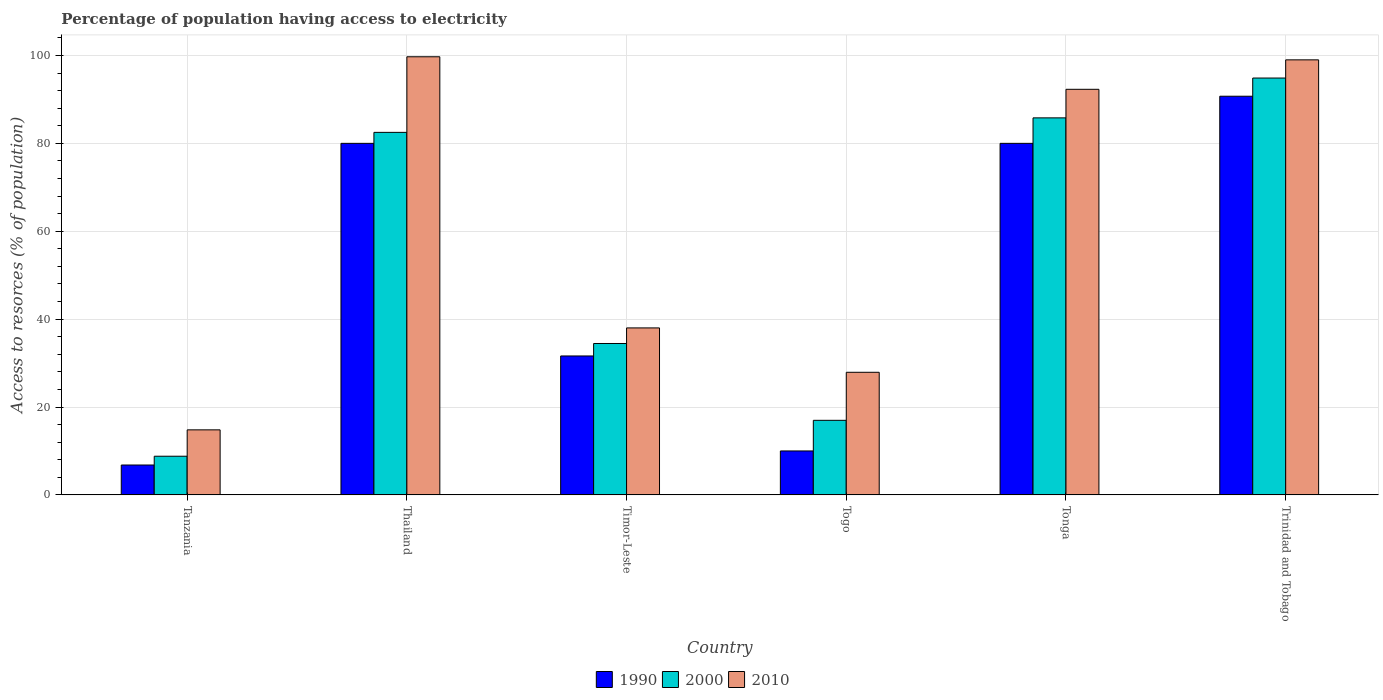How many groups of bars are there?
Your answer should be very brief. 6. Are the number of bars per tick equal to the number of legend labels?
Keep it short and to the point. Yes. Are the number of bars on each tick of the X-axis equal?
Your answer should be compact. Yes. What is the label of the 5th group of bars from the left?
Make the answer very short. Tonga. In how many cases, is the number of bars for a given country not equal to the number of legend labels?
Offer a very short reply. 0. Across all countries, what is the maximum percentage of population having access to electricity in 2010?
Provide a succinct answer. 99.7. Across all countries, what is the minimum percentage of population having access to electricity in 2010?
Give a very brief answer. 14.8. In which country was the percentage of population having access to electricity in 2010 maximum?
Give a very brief answer. Thailand. In which country was the percentage of population having access to electricity in 2000 minimum?
Provide a short and direct response. Tanzania. What is the total percentage of population having access to electricity in 2010 in the graph?
Provide a succinct answer. 371.7. What is the difference between the percentage of population having access to electricity in 1990 in Tanzania and that in Thailand?
Your answer should be very brief. -73.2. What is the difference between the percentage of population having access to electricity in 2000 in Togo and the percentage of population having access to electricity in 2010 in Thailand?
Your response must be concise. -82.73. What is the average percentage of population having access to electricity in 1990 per country?
Ensure brevity in your answer.  49.86. What is the difference between the percentage of population having access to electricity of/in 2010 and percentage of population having access to electricity of/in 1990 in Tonga?
Your answer should be very brief. 12.3. What is the ratio of the percentage of population having access to electricity in 2000 in Thailand to that in Timor-Leste?
Your answer should be compact. 2.39. Is the percentage of population having access to electricity in 2010 in Timor-Leste less than that in Trinidad and Tobago?
Your answer should be compact. Yes. Is the difference between the percentage of population having access to electricity in 2010 in Tanzania and Thailand greater than the difference between the percentage of population having access to electricity in 1990 in Tanzania and Thailand?
Your answer should be compact. No. What is the difference between the highest and the second highest percentage of population having access to electricity in 1990?
Your response must be concise. -10.72. What is the difference between the highest and the lowest percentage of population having access to electricity in 1990?
Provide a short and direct response. 83.92. In how many countries, is the percentage of population having access to electricity in 1990 greater than the average percentage of population having access to electricity in 1990 taken over all countries?
Your answer should be compact. 3. What does the 3rd bar from the right in Togo represents?
Your answer should be compact. 1990. How many bars are there?
Keep it short and to the point. 18. What is the difference between two consecutive major ticks on the Y-axis?
Ensure brevity in your answer.  20. Does the graph contain any zero values?
Make the answer very short. No. How many legend labels are there?
Give a very brief answer. 3. How are the legend labels stacked?
Your answer should be compact. Horizontal. What is the title of the graph?
Ensure brevity in your answer.  Percentage of population having access to electricity. What is the label or title of the X-axis?
Give a very brief answer. Country. What is the label or title of the Y-axis?
Provide a succinct answer. Access to resorces (% of population). What is the Access to resorces (% of population) of 1990 in Tanzania?
Provide a short and direct response. 6.8. What is the Access to resorces (% of population) in 2000 in Tanzania?
Offer a very short reply. 8.8. What is the Access to resorces (% of population) of 1990 in Thailand?
Your answer should be compact. 80. What is the Access to resorces (% of population) of 2000 in Thailand?
Keep it short and to the point. 82.5. What is the Access to resorces (% of population) of 2010 in Thailand?
Ensure brevity in your answer.  99.7. What is the Access to resorces (% of population) of 1990 in Timor-Leste?
Your response must be concise. 31.62. What is the Access to resorces (% of population) of 2000 in Timor-Leste?
Offer a terse response. 34.46. What is the Access to resorces (% of population) in 2010 in Timor-Leste?
Offer a terse response. 38. What is the Access to resorces (% of population) of 1990 in Togo?
Make the answer very short. 10. What is the Access to resorces (% of population) of 2000 in Togo?
Your answer should be very brief. 16.97. What is the Access to resorces (% of population) in 2010 in Togo?
Your response must be concise. 27.9. What is the Access to resorces (% of population) in 1990 in Tonga?
Your answer should be compact. 80. What is the Access to resorces (% of population) in 2000 in Tonga?
Make the answer very short. 85.8. What is the Access to resorces (% of population) of 2010 in Tonga?
Provide a short and direct response. 92.3. What is the Access to resorces (% of population) in 1990 in Trinidad and Tobago?
Make the answer very short. 90.72. What is the Access to resorces (% of population) of 2000 in Trinidad and Tobago?
Provide a succinct answer. 94.86. What is the Access to resorces (% of population) in 2010 in Trinidad and Tobago?
Keep it short and to the point. 99. Across all countries, what is the maximum Access to resorces (% of population) of 1990?
Your answer should be compact. 90.72. Across all countries, what is the maximum Access to resorces (% of population) of 2000?
Your answer should be very brief. 94.86. Across all countries, what is the maximum Access to resorces (% of population) in 2010?
Your answer should be compact. 99.7. Across all countries, what is the minimum Access to resorces (% of population) in 1990?
Ensure brevity in your answer.  6.8. Across all countries, what is the minimum Access to resorces (% of population) in 2010?
Offer a terse response. 14.8. What is the total Access to resorces (% of population) in 1990 in the graph?
Offer a very short reply. 299.14. What is the total Access to resorces (% of population) of 2000 in the graph?
Your response must be concise. 323.38. What is the total Access to resorces (% of population) in 2010 in the graph?
Ensure brevity in your answer.  371.7. What is the difference between the Access to resorces (% of population) of 1990 in Tanzania and that in Thailand?
Provide a short and direct response. -73.2. What is the difference between the Access to resorces (% of population) of 2000 in Tanzania and that in Thailand?
Make the answer very short. -73.7. What is the difference between the Access to resorces (% of population) of 2010 in Tanzania and that in Thailand?
Ensure brevity in your answer.  -84.9. What is the difference between the Access to resorces (% of population) in 1990 in Tanzania and that in Timor-Leste?
Give a very brief answer. -24.82. What is the difference between the Access to resorces (% of population) in 2000 in Tanzania and that in Timor-Leste?
Ensure brevity in your answer.  -25.66. What is the difference between the Access to resorces (% of population) of 2010 in Tanzania and that in Timor-Leste?
Your response must be concise. -23.2. What is the difference between the Access to resorces (% of population) of 1990 in Tanzania and that in Togo?
Offer a very short reply. -3.2. What is the difference between the Access to resorces (% of population) in 2000 in Tanzania and that in Togo?
Your response must be concise. -8.17. What is the difference between the Access to resorces (% of population) in 1990 in Tanzania and that in Tonga?
Your response must be concise. -73.2. What is the difference between the Access to resorces (% of population) in 2000 in Tanzania and that in Tonga?
Provide a succinct answer. -77. What is the difference between the Access to resorces (% of population) of 2010 in Tanzania and that in Tonga?
Give a very brief answer. -77.5. What is the difference between the Access to resorces (% of population) of 1990 in Tanzania and that in Trinidad and Tobago?
Provide a short and direct response. -83.92. What is the difference between the Access to resorces (% of population) in 2000 in Tanzania and that in Trinidad and Tobago?
Ensure brevity in your answer.  -86.06. What is the difference between the Access to resorces (% of population) of 2010 in Tanzania and that in Trinidad and Tobago?
Offer a terse response. -84.2. What is the difference between the Access to resorces (% of population) in 1990 in Thailand and that in Timor-Leste?
Ensure brevity in your answer.  48.38. What is the difference between the Access to resorces (% of population) in 2000 in Thailand and that in Timor-Leste?
Ensure brevity in your answer.  48.04. What is the difference between the Access to resorces (% of population) in 2010 in Thailand and that in Timor-Leste?
Keep it short and to the point. 61.7. What is the difference between the Access to resorces (% of population) of 1990 in Thailand and that in Togo?
Offer a very short reply. 70. What is the difference between the Access to resorces (% of population) of 2000 in Thailand and that in Togo?
Give a very brief answer. 65.53. What is the difference between the Access to resorces (% of population) in 2010 in Thailand and that in Togo?
Give a very brief answer. 71.8. What is the difference between the Access to resorces (% of population) in 2000 in Thailand and that in Tonga?
Your response must be concise. -3.3. What is the difference between the Access to resorces (% of population) of 1990 in Thailand and that in Trinidad and Tobago?
Provide a succinct answer. -10.72. What is the difference between the Access to resorces (% of population) of 2000 in Thailand and that in Trinidad and Tobago?
Your answer should be compact. -12.36. What is the difference between the Access to resorces (% of population) of 2010 in Thailand and that in Trinidad and Tobago?
Ensure brevity in your answer.  0.7. What is the difference between the Access to resorces (% of population) in 1990 in Timor-Leste and that in Togo?
Offer a very short reply. 21.62. What is the difference between the Access to resorces (% of population) in 2000 in Timor-Leste and that in Togo?
Make the answer very short. 17.49. What is the difference between the Access to resorces (% of population) of 2010 in Timor-Leste and that in Togo?
Give a very brief answer. 10.1. What is the difference between the Access to resorces (% of population) in 1990 in Timor-Leste and that in Tonga?
Keep it short and to the point. -48.38. What is the difference between the Access to resorces (% of population) of 2000 in Timor-Leste and that in Tonga?
Provide a short and direct response. -51.34. What is the difference between the Access to resorces (% of population) in 2010 in Timor-Leste and that in Tonga?
Keep it short and to the point. -54.3. What is the difference between the Access to resorces (% of population) of 1990 in Timor-Leste and that in Trinidad and Tobago?
Provide a short and direct response. -59.11. What is the difference between the Access to resorces (% of population) of 2000 in Timor-Leste and that in Trinidad and Tobago?
Keep it short and to the point. -60.41. What is the difference between the Access to resorces (% of population) of 2010 in Timor-Leste and that in Trinidad and Tobago?
Ensure brevity in your answer.  -61. What is the difference between the Access to resorces (% of population) in 1990 in Togo and that in Tonga?
Make the answer very short. -70. What is the difference between the Access to resorces (% of population) in 2000 in Togo and that in Tonga?
Give a very brief answer. -68.83. What is the difference between the Access to resorces (% of population) in 2010 in Togo and that in Tonga?
Keep it short and to the point. -64.4. What is the difference between the Access to resorces (% of population) in 1990 in Togo and that in Trinidad and Tobago?
Your response must be concise. -80.72. What is the difference between the Access to resorces (% of population) of 2000 in Togo and that in Trinidad and Tobago?
Offer a terse response. -77.89. What is the difference between the Access to resorces (% of population) of 2010 in Togo and that in Trinidad and Tobago?
Provide a succinct answer. -71.1. What is the difference between the Access to resorces (% of population) of 1990 in Tonga and that in Trinidad and Tobago?
Your answer should be very brief. -10.72. What is the difference between the Access to resorces (% of population) of 2000 in Tonga and that in Trinidad and Tobago?
Provide a short and direct response. -9.06. What is the difference between the Access to resorces (% of population) in 2010 in Tonga and that in Trinidad and Tobago?
Your answer should be very brief. -6.7. What is the difference between the Access to resorces (% of population) in 1990 in Tanzania and the Access to resorces (% of population) in 2000 in Thailand?
Give a very brief answer. -75.7. What is the difference between the Access to resorces (% of population) in 1990 in Tanzania and the Access to resorces (% of population) in 2010 in Thailand?
Provide a succinct answer. -92.9. What is the difference between the Access to resorces (% of population) in 2000 in Tanzania and the Access to resorces (% of population) in 2010 in Thailand?
Offer a very short reply. -90.9. What is the difference between the Access to resorces (% of population) in 1990 in Tanzania and the Access to resorces (% of population) in 2000 in Timor-Leste?
Provide a succinct answer. -27.66. What is the difference between the Access to resorces (% of population) in 1990 in Tanzania and the Access to resorces (% of population) in 2010 in Timor-Leste?
Provide a short and direct response. -31.2. What is the difference between the Access to resorces (% of population) of 2000 in Tanzania and the Access to resorces (% of population) of 2010 in Timor-Leste?
Give a very brief answer. -29.2. What is the difference between the Access to resorces (% of population) of 1990 in Tanzania and the Access to resorces (% of population) of 2000 in Togo?
Your response must be concise. -10.17. What is the difference between the Access to resorces (% of population) of 1990 in Tanzania and the Access to resorces (% of population) of 2010 in Togo?
Keep it short and to the point. -21.1. What is the difference between the Access to resorces (% of population) of 2000 in Tanzania and the Access to resorces (% of population) of 2010 in Togo?
Offer a terse response. -19.1. What is the difference between the Access to resorces (% of population) of 1990 in Tanzania and the Access to resorces (% of population) of 2000 in Tonga?
Provide a succinct answer. -79. What is the difference between the Access to resorces (% of population) of 1990 in Tanzania and the Access to resorces (% of population) of 2010 in Tonga?
Keep it short and to the point. -85.5. What is the difference between the Access to resorces (% of population) of 2000 in Tanzania and the Access to resorces (% of population) of 2010 in Tonga?
Ensure brevity in your answer.  -83.5. What is the difference between the Access to resorces (% of population) of 1990 in Tanzania and the Access to resorces (% of population) of 2000 in Trinidad and Tobago?
Ensure brevity in your answer.  -88.06. What is the difference between the Access to resorces (% of population) of 1990 in Tanzania and the Access to resorces (% of population) of 2010 in Trinidad and Tobago?
Provide a succinct answer. -92.2. What is the difference between the Access to resorces (% of population) of 2000 in Tanzania and the Access to resorces (% of population) of 2010 in Trinidad and Tobago?
Offer a very short reply. -90.2. What is the difference between the Access to resorces (% of population) of 1990 in Thailand and the Access to resorces (% of population) of 2000 in Timor-Leste?
Ensure brevity in your answer.  45.54. What is the difference between the Access to resorces (% of population) in 2000 in Thailand and the Access to resorces (% of population) in 2010 in Timor-Leste?
Provide a succinct answer. 44.5. What is the difference between the Access to resorces (% of population) of 1990 in Thailand and the Access to resorces (% of population) of 2000 in Togo?
Your answer should be very brief. 63.03. What is the difference between the Access to resorces (% of population) in 1990 in Thailand and the Access to resorces (% of population) in 2010 in Togo?
Keep it short and to the point. 52.1. What is the difference between the Access to resorces (% of population) of 2000 in Thailand and the Access to resorces (% of population) of 2010 in Togo?
Keep it short and to the point. 54.6. What is the difference between the Access to resorces (% of population) of 1990 in Thailand and the Access to resorces (% of population) of 2000 in Tonga?
Your response must be concise. -5.8. What is the difference between the Access to resorces (% of population) in 1990 in Thailand and the Access to resorces (% of population) in 2010 in Tonga?
Give a very brief answer. -12.3. What is the difference between the Access to resorces (% of population) in 2000 in Thailand and the Access to resorces (% of population) in 2010 in Tonga?
Your response must be concise. -9.8. What is the difference between the Access to resorces (% of population) in 1990 in Thailand and the Access to resorces (% of population) in 2000 in Trinidad and Tobago?
Your answer should be compact. -14.86. What is the difference between the Access to resorces (% of population) of 1990 in Thailand and the Access to resorces (% of population) of 2010 in Trinidad and Tobago?
Provide a succinct answer. -19. What is the difference between the Access to resorces (% of population) of 2000 in Thailand and the Access to resorces (% of population) of 2010 in Trinidad and Tobago?
Keep it short and to the point. -16.5. What is the difference between the Access to resorces (% of population) of 1990 in Timor-Leste and the Access to resorces (% of population) of 2000 in Togo?
Offer a very short reply. 14.65. What is the difference between the Access to resorces (% of population) in 1990 in Timor-Leste and the Access to resorces (% of population) in 2010 in Togo?
Give a very brief answer. 3.72. What is the difference between the Access to resorces (% of population) of 2000 in Timor-Leste and the Access to resorces (% of population) of 2010 in Togo?
Your answer should be compact. 6.56. What is the difference between the Access to resorces (% of population) in 1990 in Timor-Leste and the Access to resorces (% of population) in 2000 in Tonga?
Your answer should be very brief. -54.18. What is the difference between the Access to resorces (% of population) in 1990 in Timor-Leste and the Access to resorces (% of population) in 2010 in Tonga?
Provide a succinct answer. -60.68. What is the difference between the Access to resorces (% of population) of 2000 in Timor-Leste and the Access to resorces (% of population) of 2010 in Tonga?
Your response must be concise. -57.84. What is the difference between the Access to resorces (% of population) in 1990 in Timor-Leste and the Access to resorces (% of population) in 2000 in Trinidad and Tobago?
Offer a very short reply. -63.25. What is the difference between the Access to resorces (% of population) of 1990 in Timor-Leste and the Access to resorces (% of population) of 2010 in Trinidad and Tobago?
Your response must be concise. -67.38. What is the difference between the Access to resorces (% of population) of 2000 in Timor-Leste and the Access to resorces (% of population) of 2010 in Trinidad and Tobago?
Offer a terse response. -64.54. What is the difference between the Access to resorces (% of population) of 1990 in Togo and the Access to resorces (% of population) of 2000 in Tonga?
Ensure brevity in your answer.  -75.8. What is the difference between the Access to resorces (% of population) in 1990 in Togo and the Access to resorces (% of population) in 2010 in Tonga?
Your answer should be compact. -82.3. What is the difference between the Access to resorces (% of population) in 2000 in Togo and the Access to resorces (% of population) in 2010 in Tonga?
Make the answer very short. -75.33. What is the difference between the Access to resorces (% of population) of 1990 in Togo and the Access to resorces (% of population) of 2000 in Trinidad and Tobago?
Your answer should be very brief. -84.86. What is the difference between the Access to resorces (% of population) of 1990 in Togo and the Access to resorces (% of population) of 2010 in Trinidad and Tobago?
Your answer should be compact. -89. What is the difference between the Access to resorces (% of population) of 2000 in Togo and the Access to resorces (% of population) of 2010 in Trinidad and Tobago?
Offer a very short reply. -82.03. What is the difference between the Access to resorces (% of population) in 1990 in Tonga and the Access to resorces (% of population) in 2000 in Trinidad and Tobago?
Your response must be concise. -14.86. What is the difference between the Access to resorces (% of population) in 2000 in Tonga and the Access to resorces (% of population) in 2010 in Trinidad and Tobago?
Provide a succinct answer. -13.2. What is the average Access to resorces (% of population) of 1990 per country?
Keep it short and to the point. 49.86. What is the average Access to resorces (% of population) of 2000 per country?
Your answer should be compact. 53.9. What is the average Access to resorces (% of population) of 2010 per country?
Your answer should be very brief. 61.95. What is the difference between the Access to resorces (% of population) of 1990 and Access to resorces (% of population) of 2010 in Tanzania?
Provide a succinct answer. -8. What is the difference between the Access to resorces (% of population) in 1990 and Access to resorces (% of population) in 2010 in Thailand?
Offer a terse response. -19.7. What is the difference between the Access to resorces (% of population) of 2000 and Access to resorces (% of population) of 2010 in Thailand?
Keep it short and to the point. -17.2. What is the difference between the Access to resorces (% of population) of 1990 and Access to resorces (% of population) of 2000 in Timor-Leste?
Make the answer very short. -2.84. What is the difference between the Access to resorces (% of population) of 1990 and Access to resorces (% of population) of 2010 in Timor-Leste?
Ensure brevity in your answer.  -6.38. What is the difference between the Access to resorces (% of population) of 2000 and Access to resorces (% of population) of 2010 in Timor-Leste?
Your answer should be compact. -3.54. What is the difference between the Access to resorces (% of population) of 1990 and Access to resorces (% of population) of 2000 in Togo?
Make the answer very short. -6.97. What is the difference between the Access to resorces (% of population) of 1990 and Access to resorces (% of population) of 2010 in Togo?
Give a very brief answer. -17.9. What is the difference between the Access to resorces (% of population) in 2000 and Access to resorces (% of population) in 2010 in Togo?
Offer a very short reply. -10.93. What is the difference between the Access to resorces (% of population) of 1990 and Access to resorces (% of population) of 2000 in Tonga?
Your answer should be compact. -5.8. What is the difference between the Access to resorces (% of population) of 1990 and Access to resorces (% of population) of 2010 in Tonga?
Offer a terse response. -12.3. What is the difference between the Access to resorces (% of population) of 2000 and Access to resorces (% of population) of 2010 in Tonga?
Offer a very short reply. -6.5. What is the difference between the Access to resorces (% of population) in 1990 and Access to resorces (% of population) in 2000 in Trinidad and Tobago?
Keep it short and to the point. -4.14. What is the difference between the Access to resorces (% of population) in 1990 and Access to resorces (% of population) in 2010 in Trinidad and Tobago?
Your answer should be compact. -8.28. What is the difference between the Access to resorces (% of population) in 2000 and Access to resorces (% of population) in 2010 in Trinidad and Tobago?
Give a very brief answer. -4.14. What is the ratio of the Access to resorces (% of population) in 1990 in Tanzania to that in Thailand?
Offer a terse response. 0.09. What is the ratio of the Access to resorces (% of population) in 2000 in Tanzania to that in Thailand?
Keep it short and to the point. 0.11. What is the ratio of the Access to resorces (% of population) of 2010 in Tanzania to that in Thailand?
Offer a terse response. 0.15. What is the ratio of the Access to resorces (% of population) in 1990 in Tanzania to that in Timor-Leste?
Your answer should be very brief. 0.22. What is the ratio of the Access to resorces (% of population) in 2000 in Tanzania to that in Timor-Leste?
Ensure brevity in your answer.  0.26. What is the ratio of the Access to resorces (% of population) in 2010 in Tanzania to that in Timor-Leste?
Provide a short and direct response. 0.39. What is the ratio of the Access to resorces (% of population) of 1990 in Tanzania to that in Togo?
Offer a very short reply. 0.68. What is the ratio of the Access to resorces (% of population) of 2000 in Tanzania to that in Togo?
Offer a terse response. 0.52. What is the ratio of the Access to resorces (% of population) of 2010 in Tanzania to that in Togo?
Your answer should be compact. 0.53. What is the ratio of the Access to resorces (% of population) in 1990 in Tanzania to that in Tonga?
Offer a very short reply. 0.09. What is the ratio of the Access to resorces (% of population) in 2000 in Tanzania to that in Tonga?
Provide a succinct answer. 0.1. What is the ratio of the Access to resorces (% of population) in 2010 in Tanzania to that in Tonga?
Offer a terse response. 0.16. What is the ratio of the Access to resorces (% of population) in 1990 in Tanzania to that in Trinidad and Tobago?
Provide a short and direct response. 0.07. What is the ratio of the Access to resorces (% of population) of 2000 in Tanzania to that in Trinidad and Tobago?
Your answer should be compact. 0.09. What is the ratio of the Access to resorces (% of population) of 2010 in Tanzania to that in Trinidad and Tobago?
Your answer should be compact. 0.15. What is the ratio of the Access to resorces (% of population) in 1990 in Thailand to that in Timor-Leste?
Make the answer very short. 2.53. What is the ratio of the Access to resorces (% of population) in 2000 in Thailand to that in Timor-Leste?
Ensure brevity in your answer.  2.39. What is the ratio of the Access to resorces (% of population) in 2010 in Thailand to that in Timor-Leste?
Offer a very short reply. 2.62. What is the ratio of the Access to resorces (% of population) of 1990 in Thailand to that in Togo?
Your answer should be very brief. 8. What is the ratio of the Access to resorces (% of population) of 2000 in Thailand to that in Togo?
Make the answer very short. 4.86. What is the ratio of the Access to resorces (% of population) in 2010 in Thailand to that in Togo?
Give a very brief answer. 3.57. What is the ratio of the Access to resorces (% of population) in 2000 in Thailand to that in Tonga?
Your answer should be very brief. 0.96. What is the ratio of the Access to resorces (% of population) in 2010 in Thailand to that in Tonga?
Offer a terse response. 1.08. What is the ratio of the Access to resorces (% of population) of 1990 in Thailand to that in Trinidad and Tobago?
Provide a succinct answer. 0.88. What is the ratio of the Access to resorces (% of population) of 2000 in Thailand to that in Trinidad and Tobago?
Give a very brief answer. 0.87. What is the ratio of the Access to resorces (% of population) of 2010 in Thailand to that in Trinidad and Tobago?
Ensure brevity in your answer.  1.01. What is the ratio of the Access to resorces (% of population) of 1990 in Timor-Leste to that in Togo?
Your response must be concise. 3.16. What is the ratio of the Access to resorces (% of population) of 2000 in Timor-Leste to that in Togo?
Your answer should be compact. 2.03. What is the ratio of the Access to resorces (% of population) in 2010 in Timor-Leste to that in Togo?
Provide a succinct answer. 1.36. What is the ratio of the Access to resorces (% of population) of 1990 in Timor-Leste to that in Tonga?
Your answer should be compact. 0.4. What is the ratio of the Access to resorces (% of population) in 2000 in Timor-Leste to that in Tonga?
Your response must be concise. 0.4. What is the ratio of the Access to resorces (% of population) in 2010 in Timor-Leste to that in Tonga?
Provide a short and direct response. 0.41. What is the ratio of the Access to resorces (% of population) in 1990 in Timor-Leste to that in Trinidad and Tobago?
Offer a very short reply. 0.35. What is the ratio of the Access to resorces (% of population) in 2000 in Timor-Leste to that in Trinidad and Tobago?
Your answer should be very brief. 0.36. What is the ratio of the Access to resorces (% of population) in 2010 in Timor-Leste to that in Trinidad and Tobago?
Offer a very short reply. 0.38. What is the ratio of the Access to resorces (% of population) of 2000 in Togo to that in Tonga?
Your response must be concise. 0.2. What is the ratio of the Access to resorces (% of population) of 2010 in Togo to that in Tonga?
Offer a very short reply. 0.3. What is the ratio of the Access to resorces (% of population) of 1990 in Togo to that in Trinidad and Tobago?
Provide a succinct answer. 0.11. What is the ratio of the Access to resorces (% of population) of 2000 in Togo to that in Trinidad and Tobago?
Your answer should be very brief. 0.18. What is the ratio of the Access to resorces (% of population) of 2010 in Togo to that in Trinidad and Tobago?
Provide a succinct answer. 0.28. What is the ratio of the Access to resorces (% of population) of 1990 in Tonga to that in Trinidad and Tobago?
Offer a terse response. 0.88. What is the ratio of the Access to resorces (% of population) in 2000 in Tonga to that in Trinidad and Tobago?
Provide a short and direct response. 0.9. What is the ratio of the Access to resorces (% of population) in 2010 in Tonga to that in Trinidad and Tobago?
Ensure brevity in your answer.  0.93. What is the difference between the highest and the second highest Access to resorces (% of population) in 1990?
Give a very brief answer. 10.72. What is the difference between the highest and the second highest Access to resorces (% of population) of 2000?
Your answer should be very brief. 9.06. What is the difference between the highest and the lowest Access to resorces (% of population) in 1990?
Offer a terse response. 83.92. What is the difference between the highest and the lowest Access to resorces (% of population) of 2000?
Make the answer very short. 86.06. What is the difference between the highest and the lowest Access to resorces (% of population) in 2010?
Give a very brief answer. 84.9. 